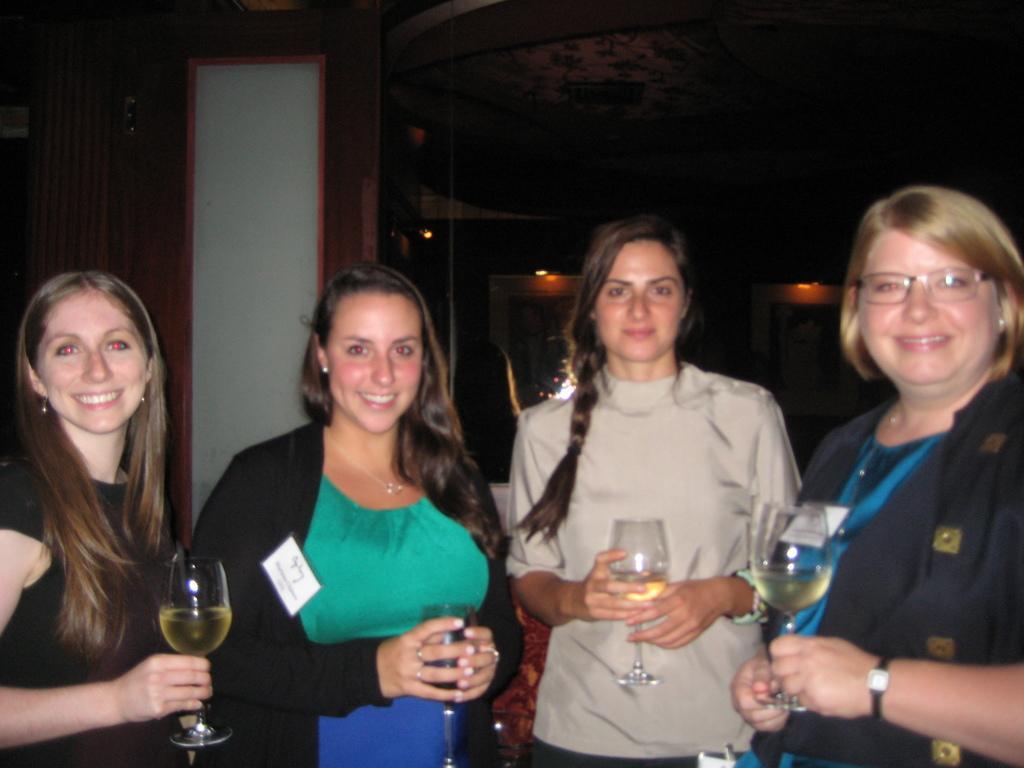Please provide a concise description of this image. There are 4 ladies standing holding a glasses with the wine in it. 